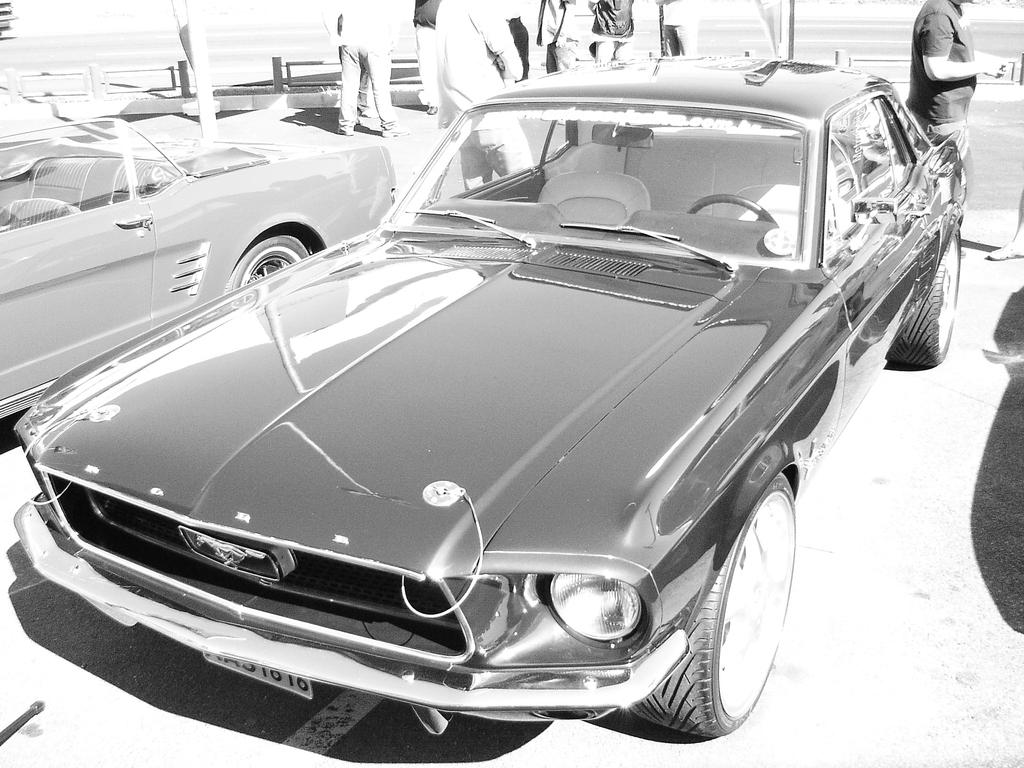What is the main feature of the image? There is a road in the image. Can you describe the people in the image? There is a group of persons towards the top of the image. What else can be seen on the road? There are cars on the road. What is the color of the background in the image? The background of the image is white in color. What type of shoe is being worn by the company in the image? There is no company or shoe present in the image. Is there a boat visible in the image? No, there is no boat present in the image. 